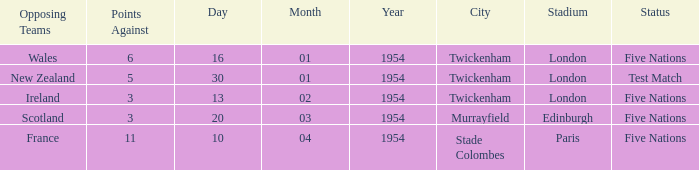What was the venue for the game played on 16/01/1954, when the against was more than 3? Twickenham , London. 